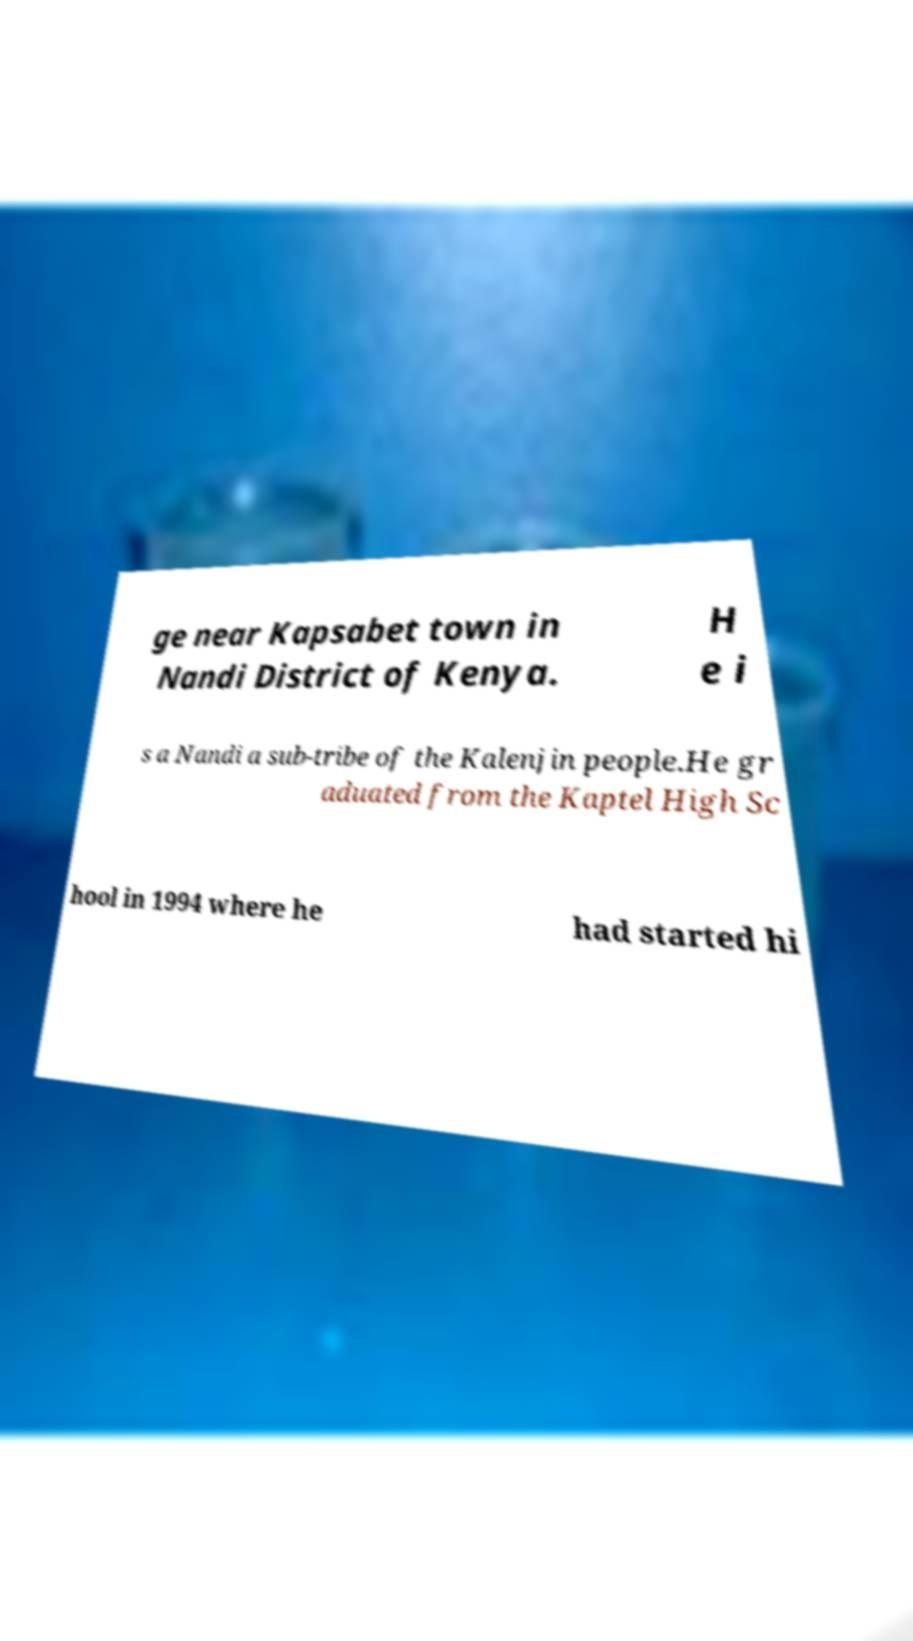There's text embedded in this image that I need extracted. Can you transcribe it verbatim? ge near Kapsabet town in Nandi District of Kenya. H e i s a Nandi a sub-tribe of the Kalenjin people.He gr aduated from the Kaptel High Sc hool in 1994 where he had started hi 